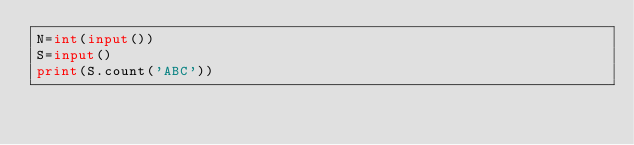<code> <loc_0><loc_0><loc_500><loc_500><_Python_>N=int(input())
S=input()
print(S.count('ABC'))
</code> 